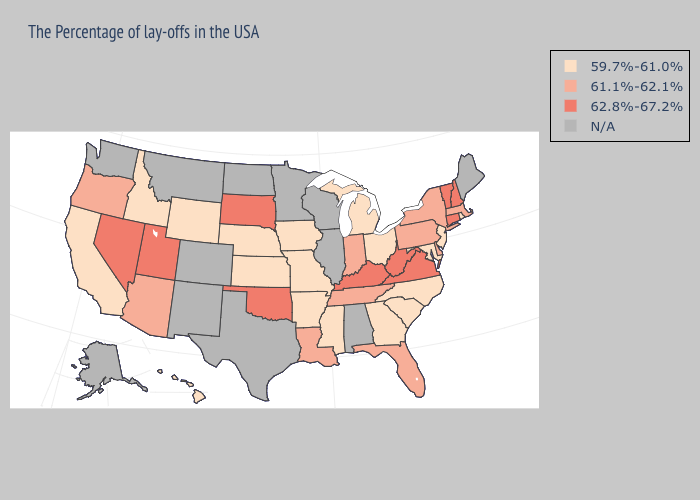Does Wyoming have the highest value in the West?
Concise answer only. No. What is the value of Georgia?
Write a very short answer. 59.7%-61.0%. Among the states that border Montana , does South Dakota have the highest value?
Quick response, please. Yes. Which states hav the highest value in the West?
Keep it brief. Utah, Nevada. Which states have the lowest value in the Northeast?
Answer briefly. Rhode Island, New Jersey. What is the value of Texas?
Quick response, please. N/A. Name the states that have a value in the range 62.8%-67.2%?
Give a very brief answer. New Hampshire, Vermont, Connecticut, Virginia, West Virginia, Kentucky, Oklahoma, South Dakota, Utah, Nevada. Name the states that have a value in the range 62.8%-67.2%?
Be succinct. New Hampshire, Vermont, Connecticut, Virginia, West Virginia, Kentucky, Oklahoma, South Dakota, Utah, Nevada. Does Idaho have the highest value in the West?
Concise answer only. No. Among the states that border Massachusetts , which have the highest value?
Write a very short answer. New Hampshire, Vermont, Connecticut. Among the states that border Georgia , does South Carolina have the lowest value?
Answer briefly. Yes. Which states have the lowest value in the USA?
Answer briefly. Rhode Island, New Jersey, Maryland, North Carolina, South Carolina, Ohio, Georgia, Michigan, Mississippi, Missouri, Arkansas, Iowa, Kansas, Nebraska, Wyoming, Idaho, California, Hawaii. 